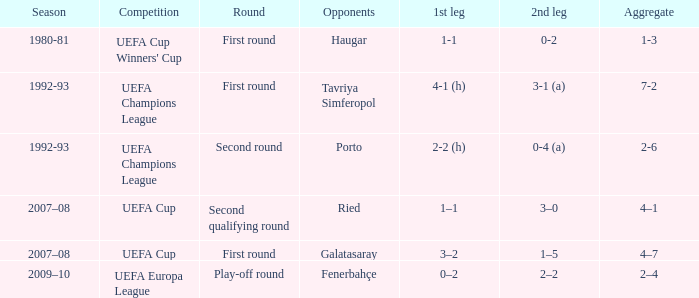 what's the 1st leg where opponents is galatasaray 3–2. 